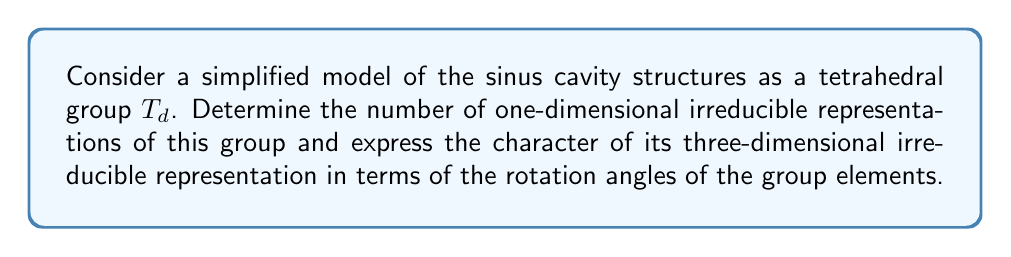Teach me how to tackle this problem. 1. The tetrahedral group $T_d$ is isomorphic to the symmetry group of a regular tetrahedron, which is relevant to the simplified structure of sinus cavities.

2. To find the number of one-dimensional irreducible representations:
   - The number of one-dimensional irreducible representations is equal to the number of abelian factor groups of $T_d$.
   - $T_d$ has order 24 and its derived subgroup $T_d'$ has order 12.
   - The factor group $T_d/T_d'$ has order 2, which is abelian.
   - Therefore, there are 2 one-dimensional irreducible representations.

3. For the character of the three-dimensional irreducible representation:
   - The character of a rotation by angle $\theta$ in three dimensions is given by:
     $$\chi(\theta) = 1 + 2\cos(\theta)$$
   - The tetrahedral group has the following classes of rotations:
     a) Identity (E): $\theta = 0°$
     b) 8 rotations by $120°$ (C$_3$)
     c) 3 rotations by $180°$ (C$_2$)
     d) 6 rotations by $90°$ (S$_4$)
     e) 6 reflections (σ$_d$)

4. Calculating the characters:
   a) $\chi(E) = 1 + 2\cos(0°) = 3$
   b) $\chi(C_3) = 1 + 2\cos(120°) = 1 + 2(-1/2) = 0$
   c) $\chi(C_2) = 1 + 2\cos(180°) = 1 + 2(-1) = -1$
   d) $\chi(S_4) = 1 + 2\cos(90°) = 1 + 2(0) = 1$
   e) $\chi(\sigma_d) = -1$ (as reflections have determinant -1)

5. The character table for the three-dimensional irreducible representation is:
   $$\begin{array}{c|ccccc}
   & E & 8C_3 & 3C_2 & 6S_4 & 6\sigma_d \\
   \hline
   \chi & 3 & 0 & -1 & 1 & -1
   \end{array}$$
Answer: 2 one-dimensional irreducible representations; Character: $\chi = (3, 0, -1, 1, -1)$ 